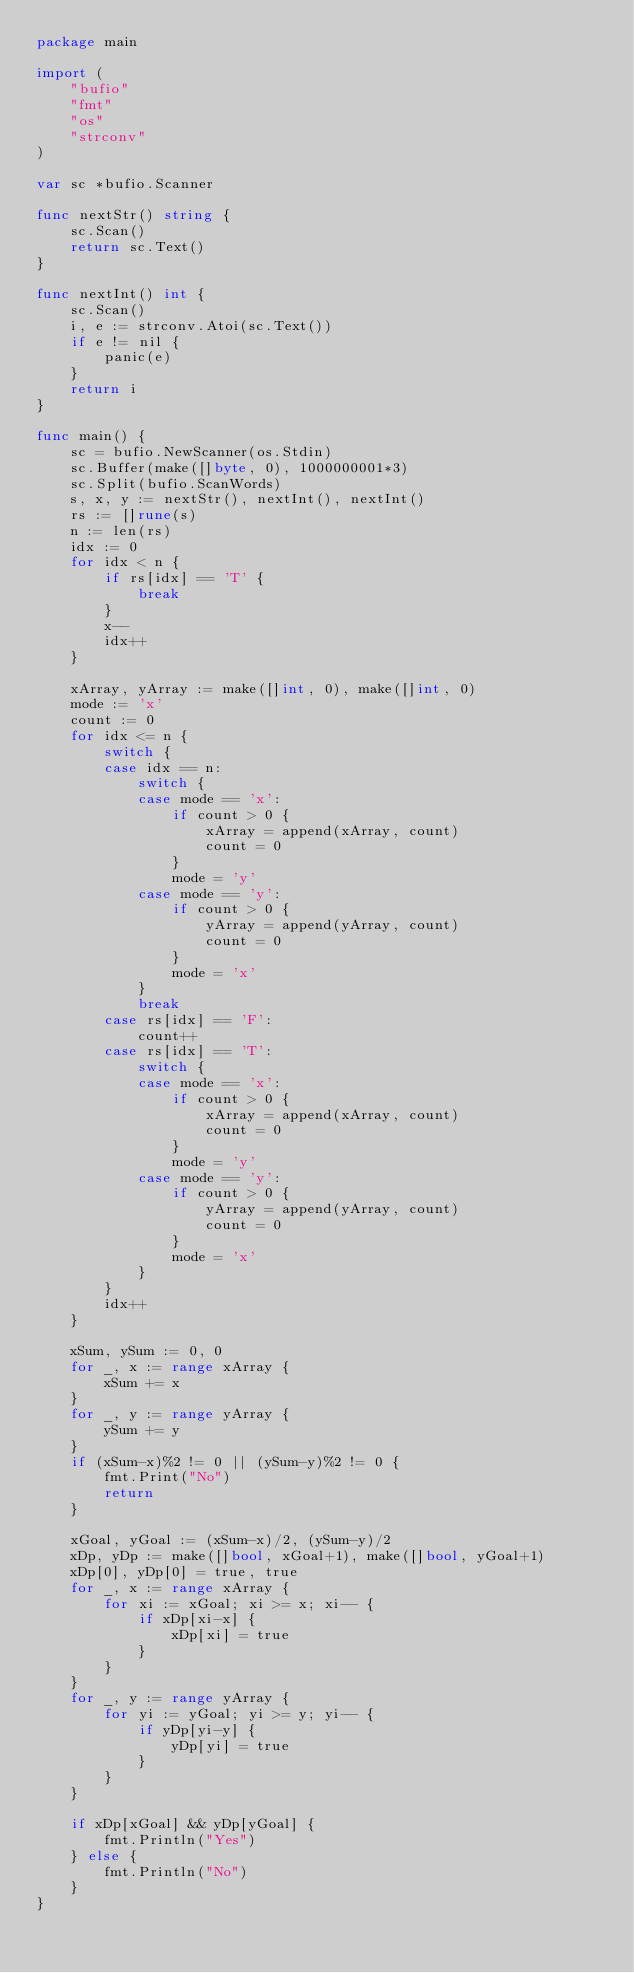Convert code to text. <code><loc_0><loc_0><loc_500><loc_500><_Go_>package main

import (
	"bufio"
	"fmt"
	"os"
	"strconv"
)

var sc *bufio.Scanner

func nextStr() string {
	sc.Scan()
	return sc.Text()
}

func nextInt() int {
	sc.Scan()
	i, e := strconv.Atoi(sc.Text())
	if e != nil {
		panic(e)
	}
	return i
}

func main() {
	sc = bufio.NewScanner(os.Stdin)
	sc.Buffer(make([]byte, 0), 1000000001*3)
	sc.Split(bufio.ScanWords)
	s, x, y := nextStr(), nextInt(), nextInt()
	rs := []rune(s)
	n := len(rs)
	idx := 0
	for idx < n {
		if rs[idx] == 'T' {
			break
		}
		x--
		idx++
	}

	xArray, yArray := make([]int, 0), make([]int, 0)
	mode := 'x'
	count := 0
	for idx <= n {
		switch {
		case idx == n:
			switch {
			case mode == 'x':
				if count > 0 {
					xArray = append(xArray, count)
					count = 0
				}
				mode = 'y'
			case mode == 'y':
				if count > 0 {
					yArray = append(yArray, count)
					count = 0
				}
				mode = 'x'
			}
			break
		case rs[idx] == 'F':
			count++
		case rs[idx] == 'T':
			switch {
			case mode == 'x':
				if count > 0 {
					xArray = append(xArray, count)
					count = 0
				}
				mode = 'y'
			case mode == 'y':
				if count > 0 {
					yArray = append(yArray, count)
					count = 0
				}
				mode = 'x'
			}
		}
		idx++
	}

	xSum, ySum := 0, 0
	for _, x := range xArray {
		xSum += x
	}
	for _, y := range yArray {
		ySum += y
	}
	if (xSum-x)%2 != 0 || (ySum-y)%2 != 0 {
		fmt.Print("No")
		return
	}

	xGoal, yGoal := (xSum-x)/2, (ySum-y)/2
	xDp, yDp := make([]bool, xGoal+1), make([]bool, yGoal+1)
	xDp[0], yDp[0] = true, true
	for _, x := range xArray {
		for xi := xGoal; xi >= x; xi-- {
			if xDp[xi-x] {
				xDp[xi] = true
			}
		}
	}
	for _, y := range yArray {
		for yi := yGoal; yi >= y; yi-- {
			if yDp[yi-y] {
				yDp[yi] = true
			}
		}
	}

	if xDp[xGoal] && yDp[yGoal] {
		fmt.Println("Yes")
	} else {
		fmt.Println("No")
	}
}
</code> 